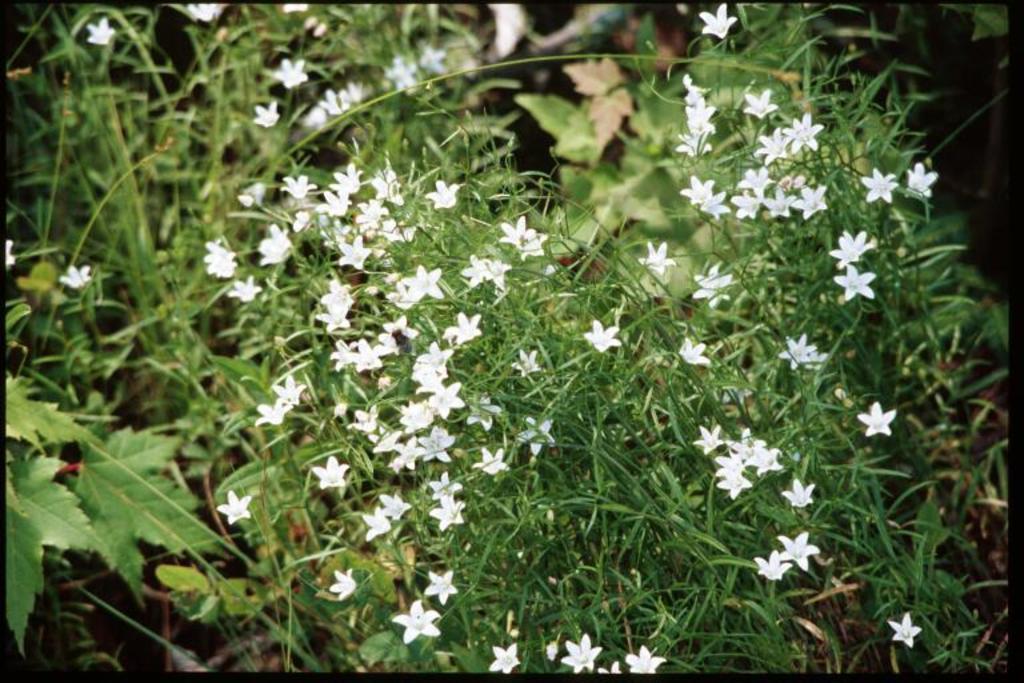Can you describe this image briefly? In this image in the foreground there are some plants and flowers, and in the background there are leaves. 